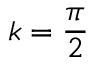Convert formula to latex. <formula><loc_0><loc_0><loc_500><loc_500>k = \frac { \pi } { 2 }</formula> 